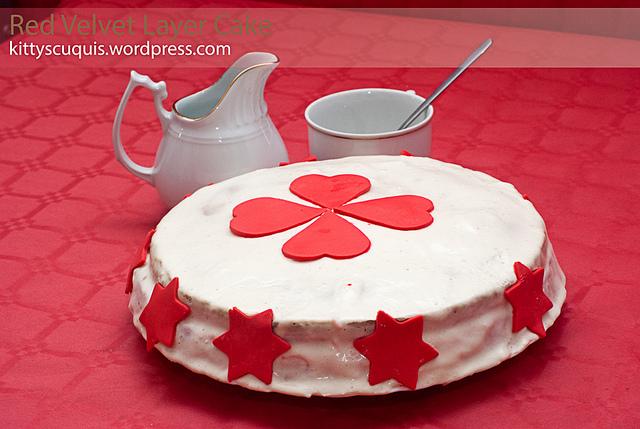What color is the frosting?
Give a very brief answer. White. What kind of icing is this?
Answer briefly. White. If you cut the cake, what color will the inside be?
Concise answer only. Red. Is the cake for a child?
Write a very short answer. Yes. Are there flowers near the cake?
Give a very brief answer. No. What website is this photo from?
Keep it brief. Kittyscuquiswordpresscom. What color is the background?
Short answer required. Red. What is the round object?
Concise answer only. Cake. What is this cake decorated of?
Write a very short answer. Hearts and stars. 